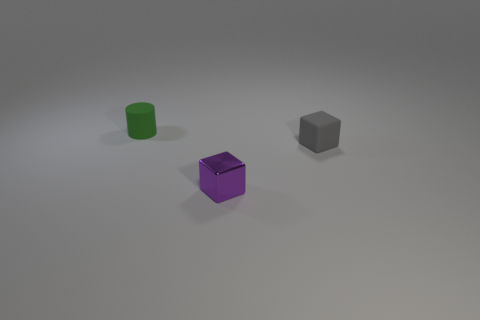Add 1 yellow balls. How many objects exist? 4 Subtract all cylinders. How many objects are left? 2 Add 2 tiny yellow rubber blocks. How many tiny yellow rubber blocks exist? 2 Subtract 1 gray cubes. How many objects are left? 2 Subtract all purple metallic cubes. Subtract all tiny gray cubes. How many objects are left? 1 Add 2 rubber objects. How many rubber objects are left? 4 